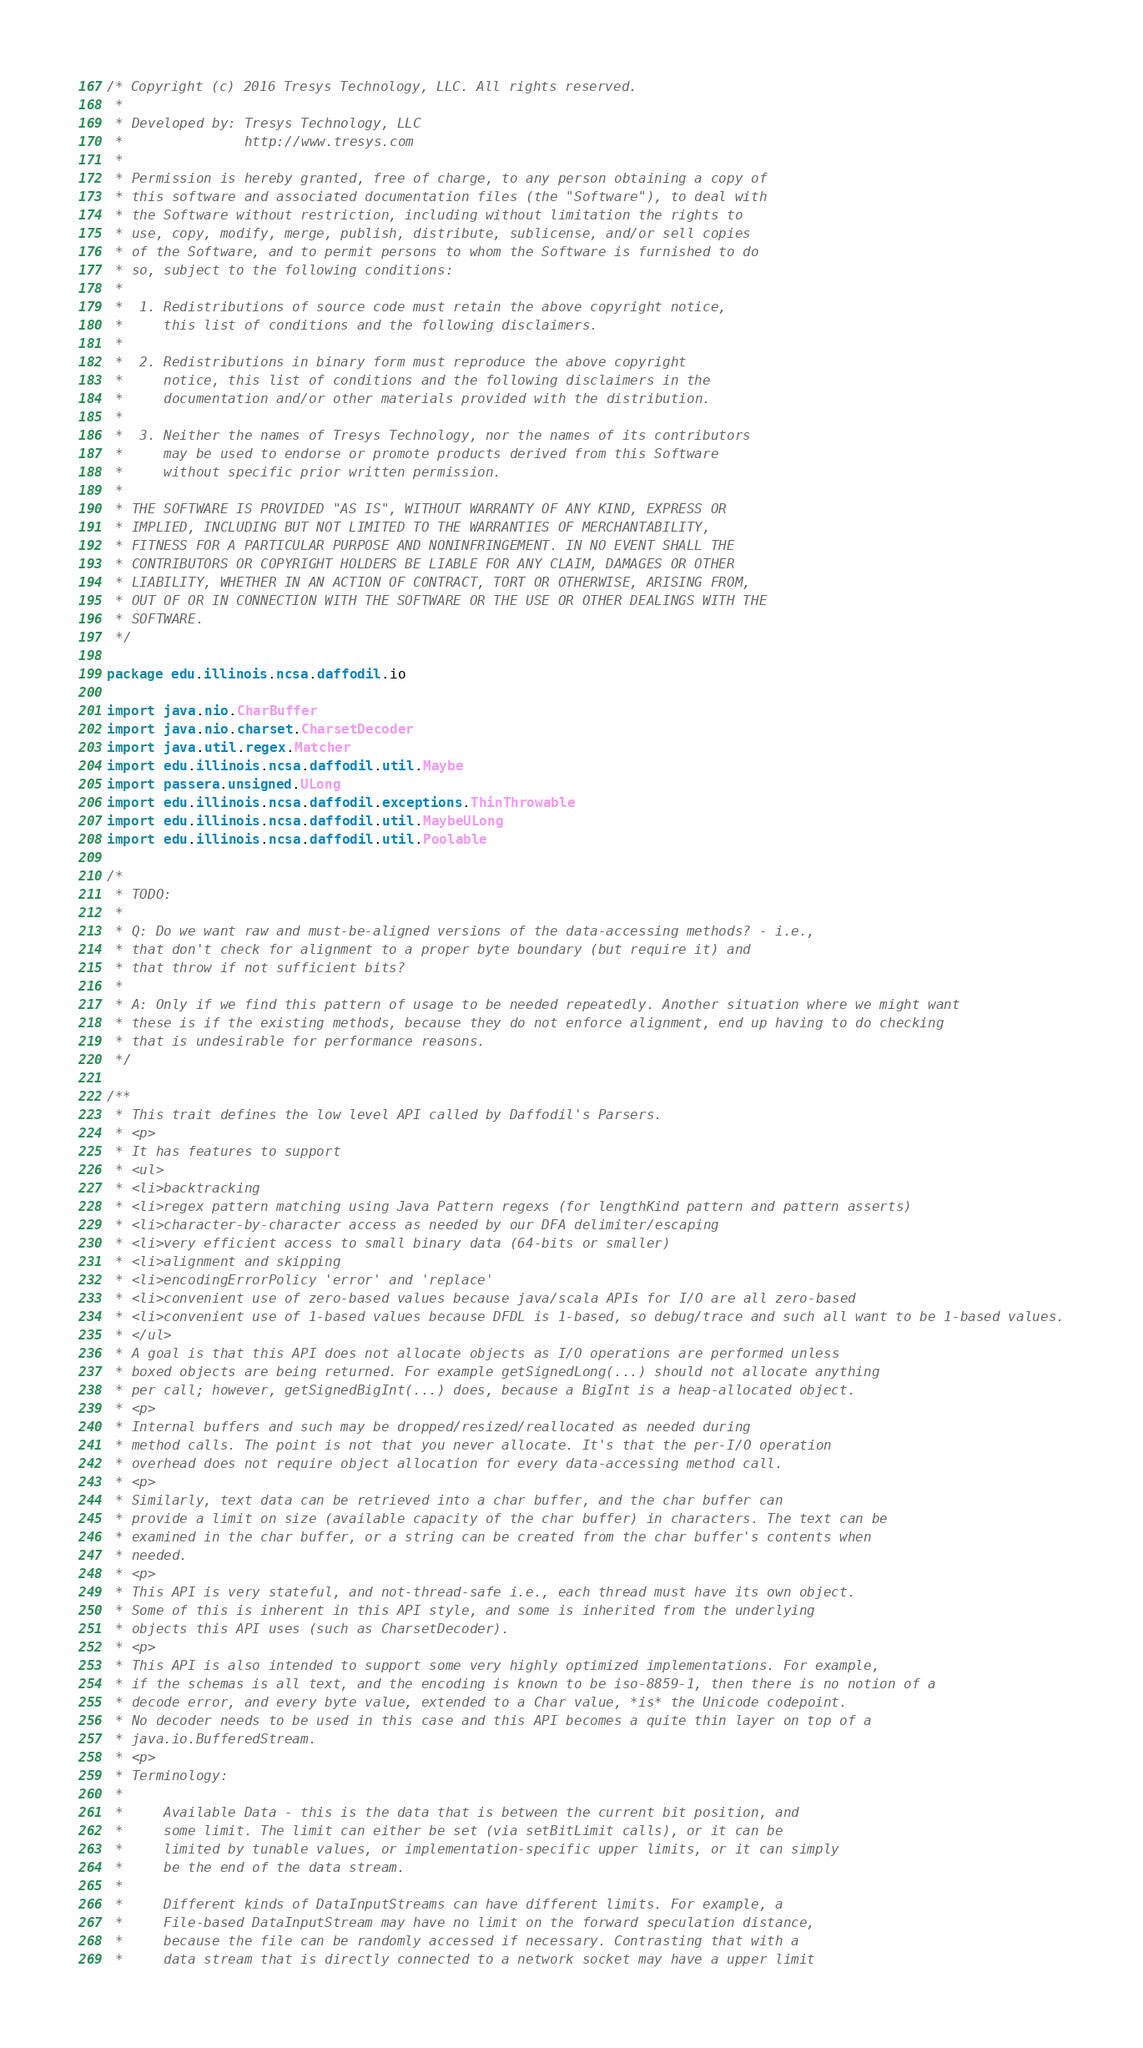Convert code to text. <code><loc_0><loc_0><loc_500><loc_500><_Scala_>/* Copyright (c) 2016 Tresys Technology, LLC. All rights reserved.
 *
 * Developed by: Tresys Technology, LLC
 *               http://www.tresys.com
 *
 * Permission is hereby granted, free of charge, to any person obtaining a copy of
 * this software and associated documentation files (the "Software"), to deal with
 * the Software without restriction, including without limitation the rights to
 * use, copy, modify, merge, publish, distribute, sublicense, and/or sell copies
 * of the Software, and to permit persons to whom the Software is furnished to do
 * so, subject to the following conditions:
 *
 *  1. Redistributions of source code must retain the above copyright notice,
 *     this list of conditions and the following disclaimers.
 *
 *  2. Redistributions in binary form must reproduce the above copyright
 *     notice, this list of conditions and the following disclaimers in the
 *     documentation and/or other materials provided with the distribution.
 *
 *  3. Neither the names of Tresys Technology, nor the names of its contributors
 *     may be used to endorse or promote products derived from this Software
 *     without specific prior written permission.
 *
 * THE SOFTWARE IS PROVIDED "AS IS", WITHOUT WARRANTY OF ANY KIND, EXPRESS OR
 * IMPLIED, INCLUDING BUT NOT LIMITED TO THE WARRANTIES OF MERCHANTABILITY,
 * FITNESS FOR A PARTICULAR PURPOSE AND NONINFRINGEMENT. IN NO EVENT SHALL THE
 * CONTRIBUTORS OR COPYRIGHT HOLDERS BE LIABLE FOR ANY CLAIM, DAMAGES OR OTHER
 * LIABILITY, WHETHER IN AN ACTION OF CONTRACT, TORT OR OTHERWISE, ARISING FROM,
 * OUT OF OR IN CONNECTION WITH THE SOFTWARE OR THE USE OR OTHER DEALINGS WITH THE
 * SOFTWARE.
 */

package edu.illinois.ncsa.daffodil.io

import java.nio.CharBuffer
import java.nio.charset.CharsetDecoder
import java.util.regex.Matcher
import edu.illinois.ncsa.daffodil.util.Maybe
import passera.unsigned.ULong
import edu.illinois.ncsa.daffodil.exceptions.ThinThrowable
import edu.illinois.ncsa.daffodil.util.MaybeULong
import edu.illinois.ncsa.daffodil.util.Poolable

/*
 * TODO:
 *
 * Q: Do we want raw and must-be-aligned versions of the data-accessing methods? - i.e.,
 * that don't check for alignment to a proper byte boundary (but require it) and
 * that throw if not sufficient bits?
 *
 * A: Only if we find this pattern of usage to be needed repeatedly. Another situation where we might want
 * these is if the existing methods, because they do not enforce alignment, end up having to do checking
 * that is undesirable for performance reasons.
 */

/**
 * This trait defines the low level API called by Daffodil's Parsers.
 * <p>
 * It has features to support
 * <ul>
 * <li>backtracking
 * <li>regex pattern matching using Java Pattern regexs (for lengthKind pattern and pattern asserts)
 * <li>character-by-character access as needed by our DFA delimiter/escaping
 * <li>very efficient access to small binary data (64-bits or smaller)
 * <li>alignment and skipping
 * <li>encodingErrorPolicy 'error' and 'replace'
 * <li>convenient use of zero-based values because java/scala APIs for I/O are all zero-based
 * <li>convenient use of 1-based values because DFDL is 1-based, so debug/trace and such all want to be 1-based values.
 * </ul>
 * A goal is that this API does not allocate objects as I/O operations are performed unless
 * boxed objects are being returned. For example getSignedLong(...) should not allocate anything
 * per call; however, getSignedBigInt(...) does, because a BigInt is a heap-allocated object.
 * <p>
 * Internal buffers and such may be dropped/resized/reallocated as needed during
 * method calls. The point is not that you never allocate. It's that the per-I/O operation
 * overhead does not require object allocation for every data-accessing method call.
 * <p>
 * Similarly, text data can be retrieved into a char buffer, and the char buffer can
 * provide a limit on size (available capacity of the char buffer) in characters. The text can be
 * examined in the char buffer, or a string can be created from the char buffer's contents when
 * needed.
 * <p>
 * This API is very stateful, and not-thread-safe i.e., each thread must have its own object.
 * Some of this is inherent in this API style, and some is inherited from the underlying
 * objects this API uses (such as CharsetDecoder).
 * <p>
 * This API is also intended to support some very highly optimized implementations. For example,
 * if the schemas is all text, and the encoding is known to be iso-8859-1, then there is no notion of a
 * decode error, and every byte value, extended to a Char value, *is* the Unicode codepoint.
 * No decoder needs to be used in this case and this API becomes a quite thin layer on top of a
 * java.io.BufferedStream.
 * <p>
 * Terminology:
 *
 *     Available Data - this is the data that is between the current bit position, and
 *     some limit. The limit can either be set (via setBitLimit calls), or it can be
 *     limited by tunable values, or implementation-specific upper limits, or it can simply
 *     be the end of the data stream.
 *
 *     Different kinds of DataInputStreams can have different limits. For example, a
 *     File-based DataInputStream may have no limit on the forward speculation distance,
 *     because the file can be randomly accessed if necessary. Contrasting that with a
 *     data stream that is directly connected to a network socket may have a upper limit</code> 